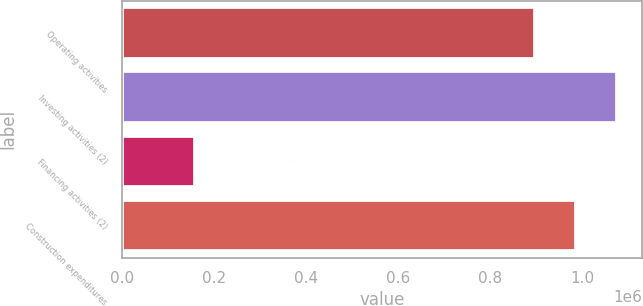Convert chart. <chart><loc_0><loc_0><loc_500><loc_500><bar_chart><fcel>Operating activities<fcel>Investing activities (2)<fcel>Financing activities (2)<fcel>Construction expenditures<nl><fcel>896162<fcel>1.07489e+06<fcel>159663<fcel>985525<nl></chart> 